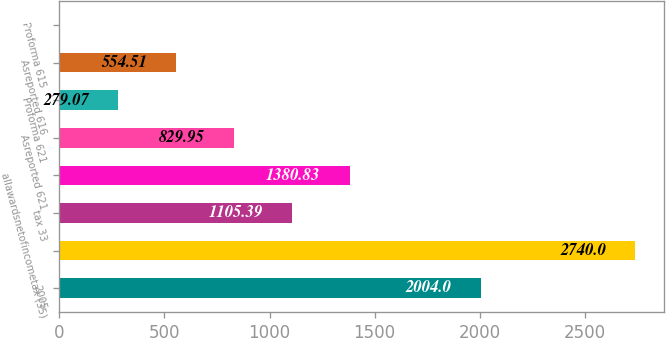Convert chart to OTSL. <chart><loc_0><loc_0><loc_500><loc_500><bar_chart><fcel>2005<fcel>Unnamed: 1<fcel>tax 33<fcel>allawardsnetofincometax (35)<fcel>Asreported 621<fcel>Proforma 621<fcel>Asreported 616<fcel>Proforma 615<nl><fcel>2004<fcel>2740<fcel>1105.39<fcel>1380.83<fcel>829.95<fcel>279.07<fcel>554.51<fcel>3.63<nl></chart> 